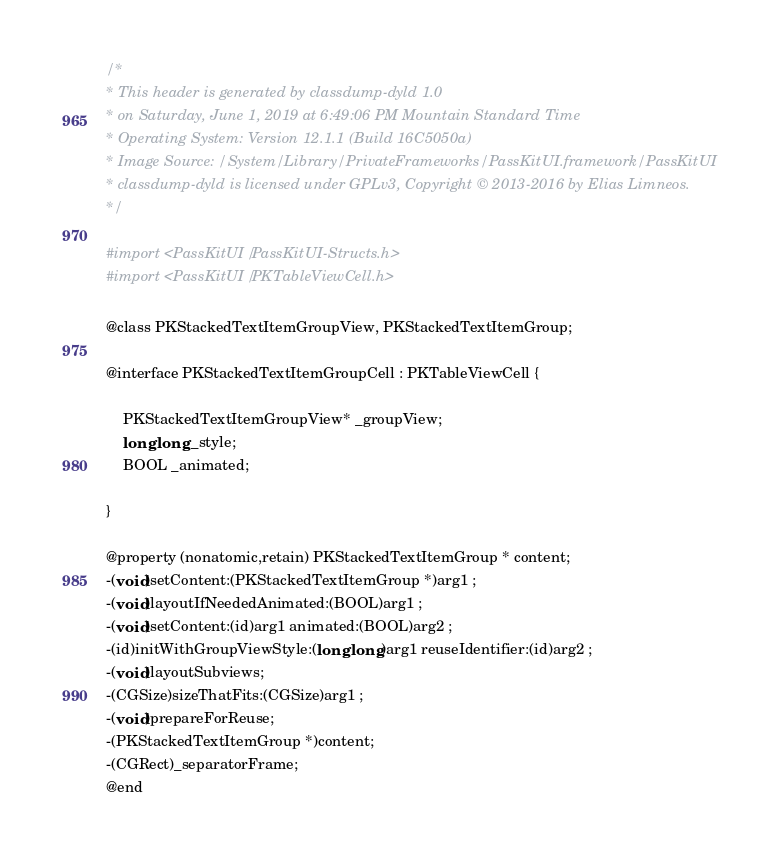<code> <loc_0><loc_0><loc_500><loc_500><_C_>/*
* This header is generated by classdump-dyld 1.0
* on Saturday, June 1, 2019 at 6:49:06 PM Mountain Standard Time
* Operating System: Version 12.1.1 (Build 16C5050a)
* Image Source: /System/Library/PrivateFrameworks/PassKitUI.framework/PassKitUI
* classdump-dyld is licensed under GPLv3, Copyright © 2013-2016 by Elias Limneos.
*/

#import <PassKitUI/PassKitUI-Structs.h>
#import <PassKitUI/PKTableViewCell.h>

@class PKStackedTextItemGroupView, PKStackedTextItemGroup;

@interface PKStackedTextItemGroupCell : PKTableViewCell {

	PKStackedTextItemGroupView* _groupView;
	long long _style;
	BOOL _animated;

}

@property (nonatomic,retain) PKStackedTextItemGroup * content; 
-(void)setContent:(PKStackedTextItemGroup *)arg1 ;
-(void)layoutIfNeededAnimated:(BOOL)arg1 ;
-(void)setContent:(id)arg1 animated:(BOOL)arg2 ;
-(id)initWithGroupViewStyle:(long long)arg1 reuseIdentifier:(id)arg2 ;
-(void)layoutSubviews;
-(CGSize)sizeThatFits:(CGSize)arg1 ;
-(void)prepareForReuse;
-(PKStackedTextItemGroup *)content;
-(CGRect)_separatorFrame;
@end

</code> 